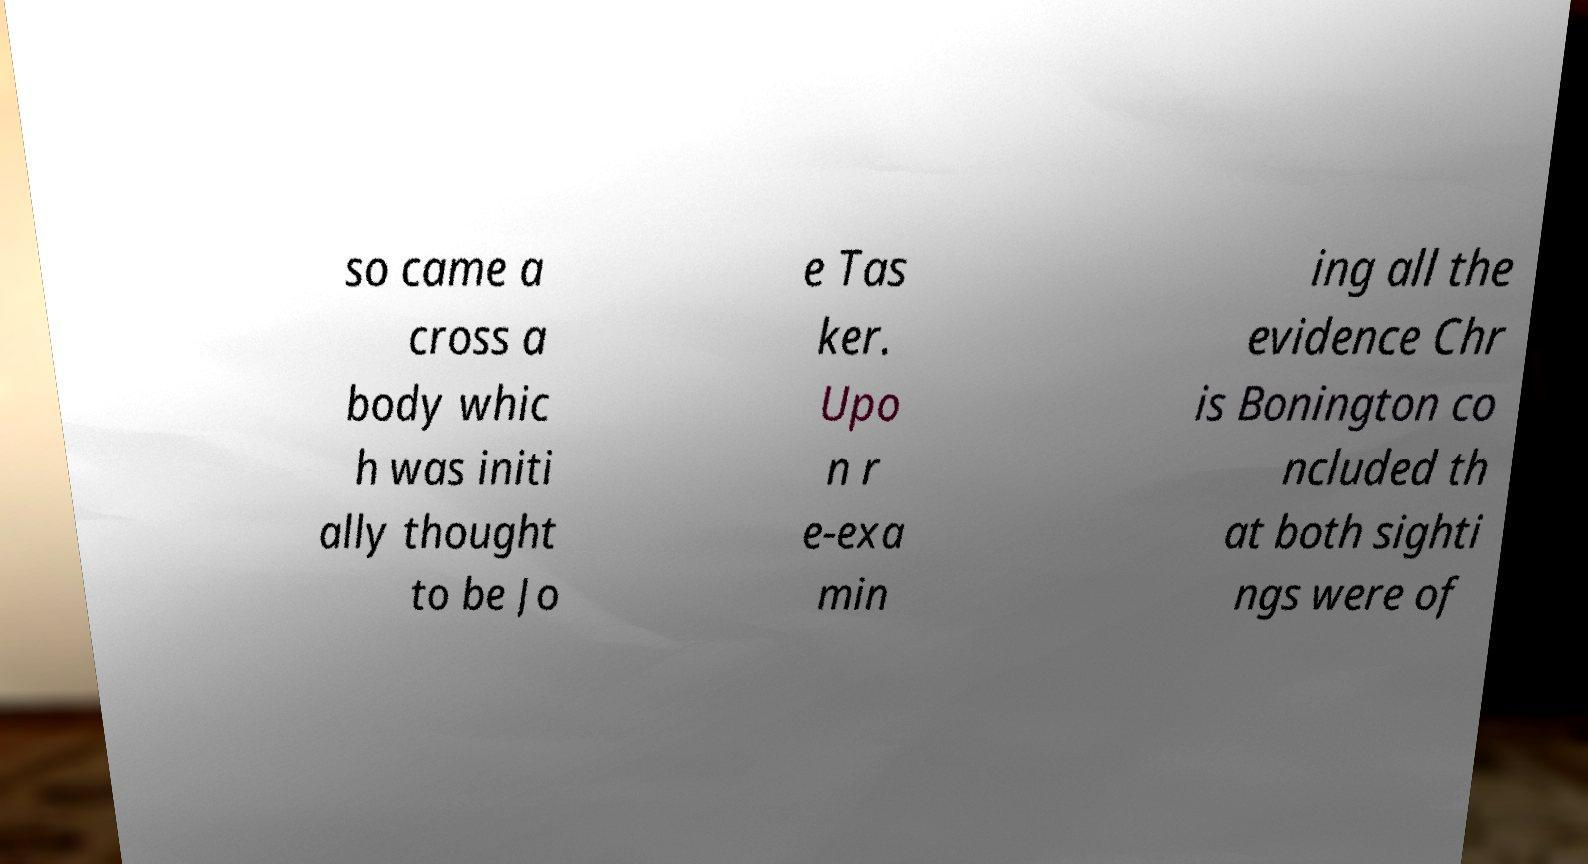Please read and relay the text visible in this image. What does it say? so came a cross a body whic h was initi ally thought to be Jo e Tas ker. Upo n r e-exa min ing all the evidence Chr is Bonington co ncluded th at both sighti ngs were of 